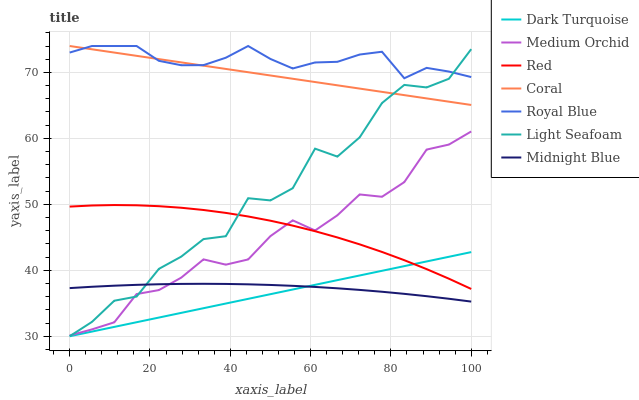Does Coral have the minimum area under the curve?
Answer yes or no. No. Does Coral have the maximum area under the curve?
Answer yes or no. No. Is Dark Turquoise the smoothest?
Answer yes or no. No. Is Dark Turquoise the roughest?
Answer yes or no. No. Does Coral have the lowest value?
Answer yes or no. No. Does Dark Turquoise have the highest value?
Answer yes or no. No. Is Dark Turquoise less than Coral?
Answer yes or no. Yes. Is Royal Blue greater than Medium Orchid?
Answer yes or no. Yes. Does Dark Turquoise intersect Coral?
Answer yes or no. No. 